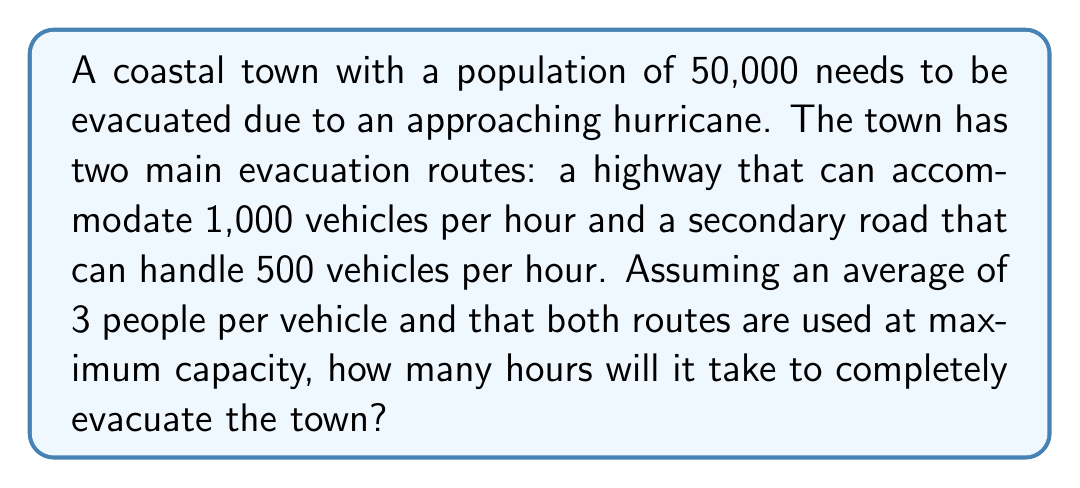What is the answer to this math problem? Let's approach this step-by-step:

1. Calculate the total number of vehicles needed:
   $$\text{Total vehicles} = \frac{\text{Total population}}{\text{People per vehicle}} = \frac{50,000}{3} \approx 16,667 \text{ vehicles}$$

2. Calculate the total vehicle capacity per hour:
   $$\text{Total capacity} = \text{Highway capacity} + \text{Secondary road capacity}$$
   $$\text{Total capacity} = 1,000 + 500 = 1,500 \text{ vehicles/hour}$$

3. Calculate the time needed for evacuation:
   $$\text{Time} = \frac{\text{Total vehicles}}{\text{Total capacity per hour}}$$
   $$\text{Time} = \frac{16,667}{1,500} \approx 11.11 \text{ hours}$$

4. Round up to the nearest hour, as we can't have a partial hour in this context:
   $$\text{Evacuation time} = 12 \text{ hours}$$
Answer: 12 hours 